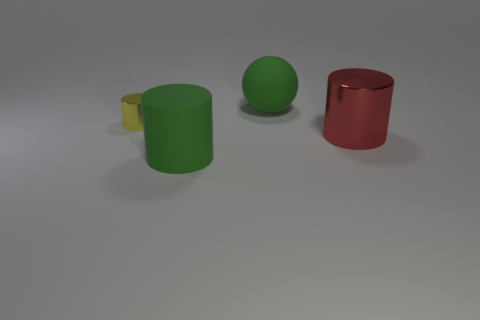Add 2 small brown cylinders. How many objects exist? 6 Subtract all spheres. How many objects are left? 3 Subtract all green rubber things. Subtract all brown metal cubes. How many objects are left? 2 Add 4 metal objects. How many metal objects are left? 6 Add 1 big red metallic things. How many big red metallic things exist? 2 Subtract 0 gray balls. How many objects are left? 4 